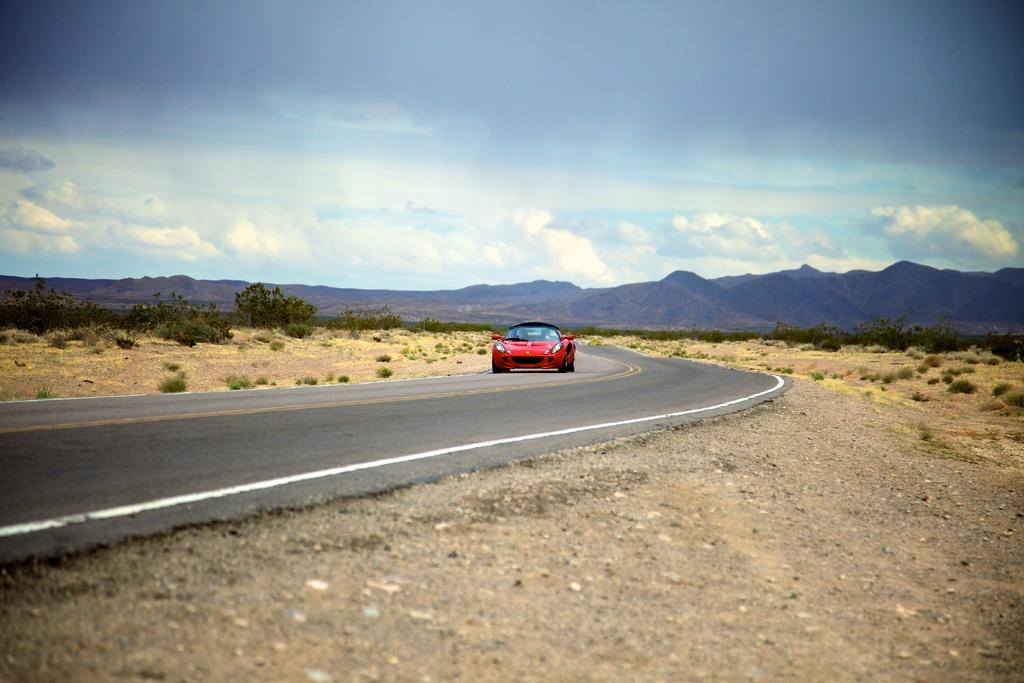What is the main subject of the image? There is a car on the road in the image. What can be seen on the ground in the image? There are trees on the ground in the image. What is visible in the background of the image? Mountains and the sky are visible in the background of the image. What is the condition of the sky in the image? Clouds are present in the sky. Where is the tent set up in the image? There is no tent present in the image. What type of harmony is being played in the background of the image? There is no music or harmony present in the image; it is a still image of a car, trees, mountains, and sky. 